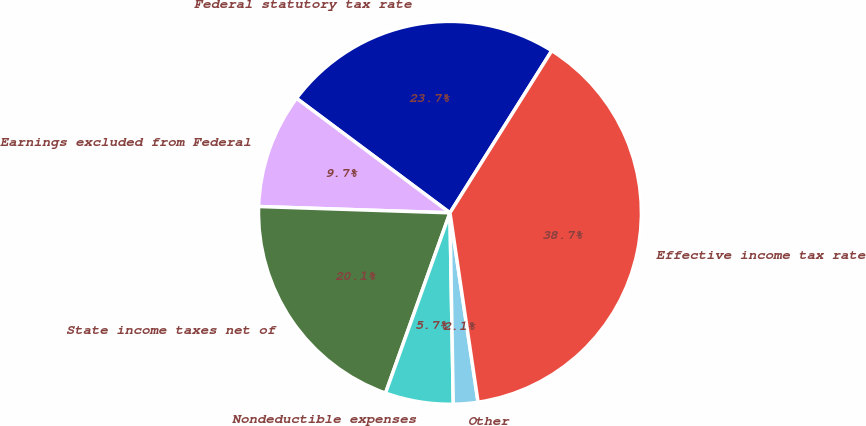Convert chart to OTSL. <chart><loc_0><loc_0><loc_500><loc_500><pie_chart><fcel>Federal statutory tax rate<fcel>Earnings excluded from Federal<fcel>State income taxes net of<fcel>Nondeductible expenses<fcel>Other<fcel>Effective income tax rate<nl><fcel>23.72%<fcel>9.68%<fcel>20.06%<fcel>5.74%<fcel>2.07%<fcel>38.73%<nl></chart> 